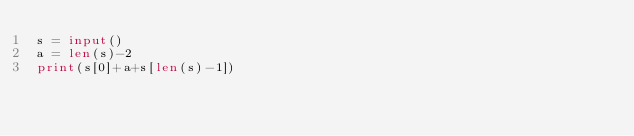Convert code to text. <code><loc_0><loc_0><loc_500><loc_500><_Python_>s = input()
a = len(s)-2
print(s[0]+a+s[len(s)-1])</code> 